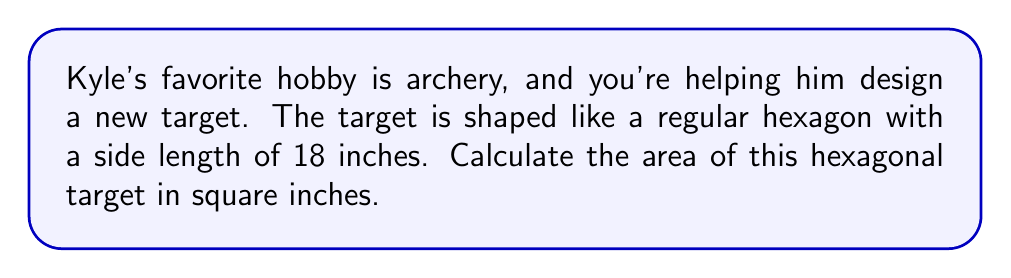Could you help me with this problem? Let's approach this step-by-step:

1) The area of a regular hexagon can be calculated using the formula:

   $$A = \frac{3\sqrt{3}}{2}s^2$$

   where $s$ is the length of one side.

2) We're given that $s = 18$ inches.

3) Let's substitute this into our formula:

   $$A = \frac{3\sqrt{3}}{2}(18)^2$$

4) Let's simplify inside the parentheses first:

   $$A = \frac{3\sqrt{3}}{2}(324)$$

5) Now multiply:

   $$A = 486\sqrt{3}$$

6) To get a decimal approximation, let's multiply this out:

   $$A \approx 486 * 1.732050808 \approx 841.8 \text{ square inches}$$

7) Rounding to the nearest whole number:

   $$A \approx 842 \text{ square inches}$$

[asy]
import geometry;

size(200);
real s = 3;
pair A = (s*sqrt(3)/2, s/2);
pair B = (0, s);
pair C = (-s*sqrt(3)/2, s/2);
pair D = (-s*sqrt(3)/2, -s/2);
pair E = (0, -s);
pair F = (s*sqrt(3)/2, -s/2);

draw(A--B--C--D--E--F--cycle);
label("18\"", (A+B)/2, E, fontsize(10pt));
[/asy]
Answer: 842 sq in 